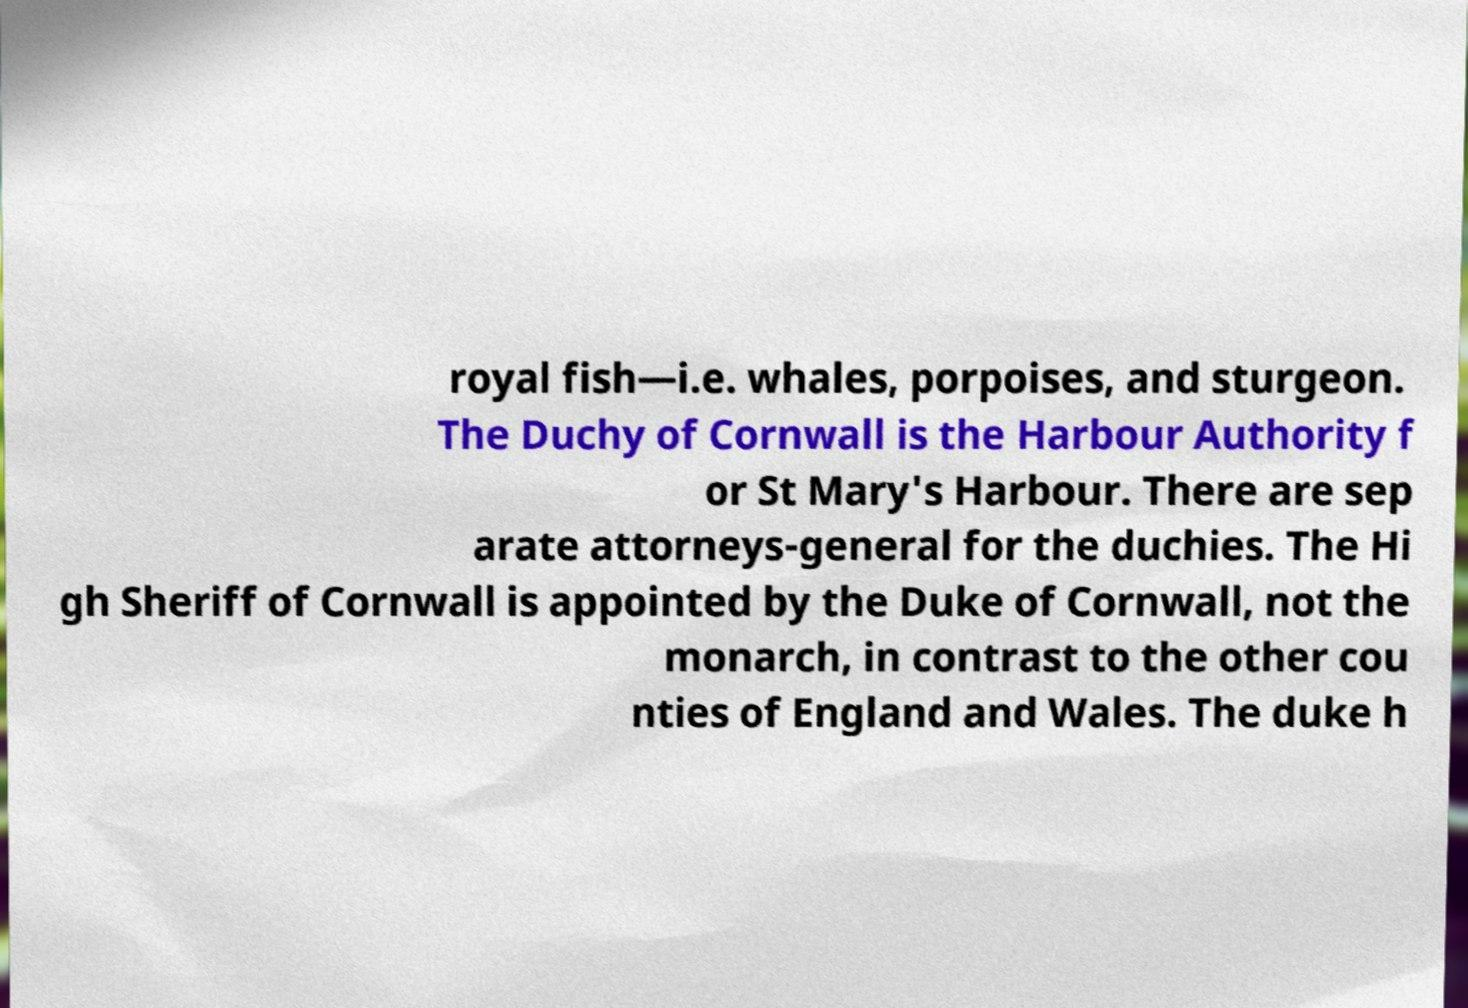Can you accurately transcribe the text from the provided image for me? royal fish—i.e. whales, porpoises, and sturgeon. The Duchy of Cornwall is the Harbour Authority f or St Mary's Harbour. There are sep arate attorneys-general for the duchies. The Hi gh Sheriff of Cornwall is appointed by the Duke of Cornwall, not the monarch, in contrast to the other cou nties of England and Wales. The duke h 